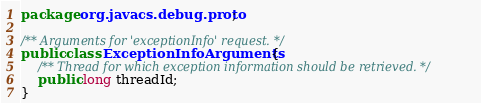Convert code to text. <code><loc_0><loc_0><loc_500><loc_500><_Java_>package org.javacs.debug.proto;

/** Arguments for 'exceptionInfo' request. */
public class ExceptionInfoArguments {
    /** Thread for which exception information should be retrieved. */
    public long threadId;
}
</code> 